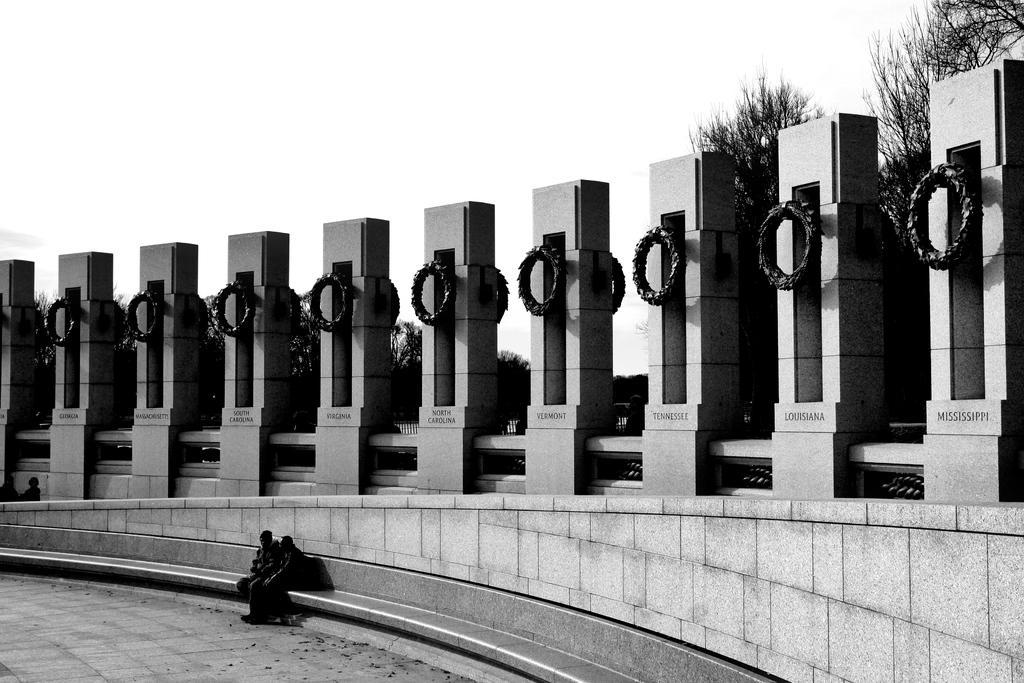What is the color scheme of the image? The image is black and white. What can be seen in the sky in the image? There is sky visible in the image. What type of natural vegetation is present in the image? There are trees in the image. What architectural features can be seen in the image? There are pillars present in the image. What man-made objects are visible in the image? Name boards are visible in the image. What are the people in the image doing? Persons are sitting on the pavement in the image. Can you see any ghosts in the image? There are no ghosts present in the image; it is a black and white image featuring trees, pillars, name boards, and people sitting on the pavement. How many times do the people in the image look at the camera? The provided facts do not mention the people looking at the camera, so it cannot be determined from the image. 